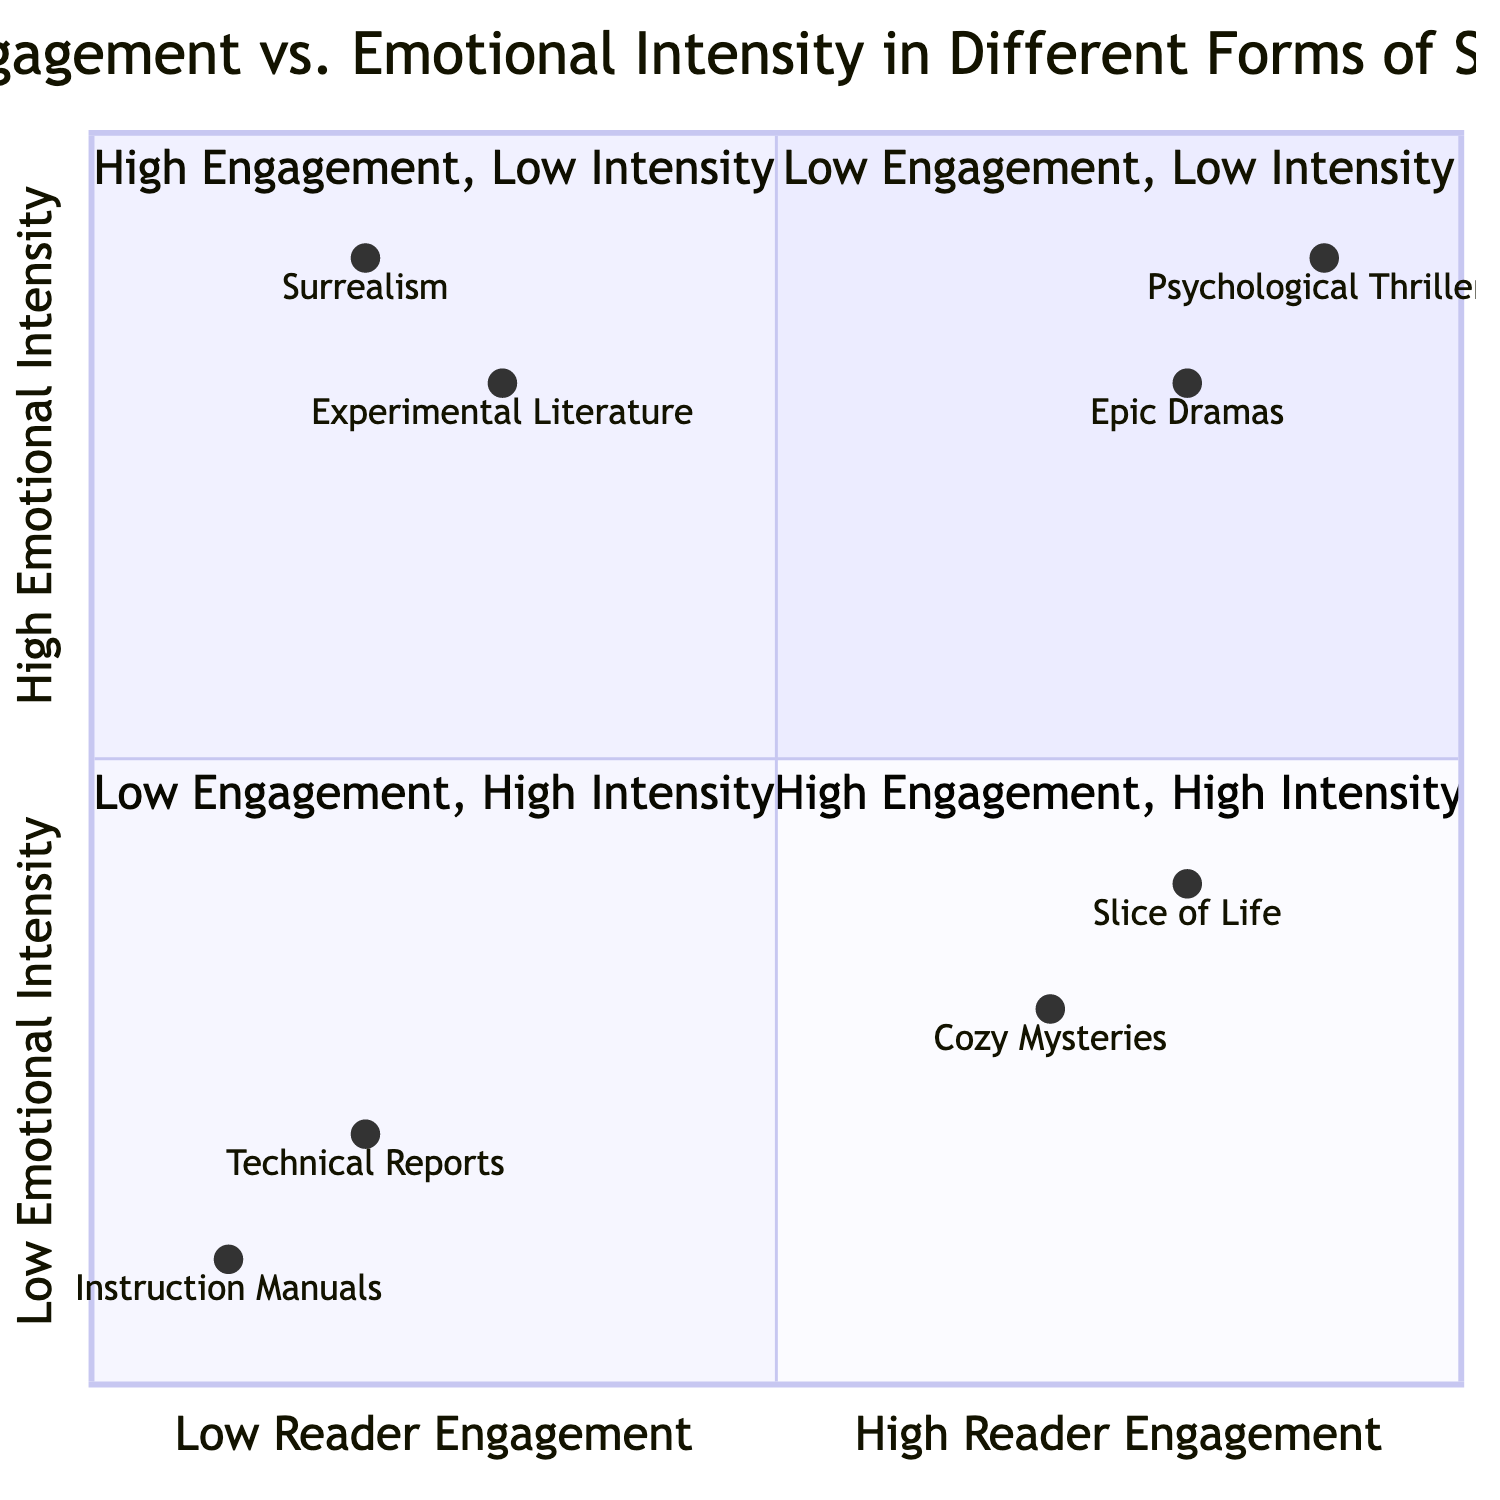What is the title of the diagram? The title is explicitly stated at the top of the diagram, which is "Reader Engagement vs. Emotional Intensity in Different Forms of Storytelling."
Answer: Reader Engagement vs. Emotional Intensity in Different Forms of Storytelling Which example has the highest reader engagement? In the quadrant titled "High Engagement, High Intensity," both "Psychological Thrillers" and "Epic Dramas" are located at high engagement levels, but "Psychological Thrillers" is further to the right on the x-axis, indicating it has the highest reader engagement.
Answer: Psychological Thrillers How many examples are in the "Low Engagement, High Intensity" quadrant? The "Low Engagement, High Intensity" quadrant contains two examples: "Experimental Literature" and "Surrealism," indicating there are a total of two examples present.
Answer: 2 What is the emotional intensity of "Cozy Mysteries"? The "Cozy Mysteries" is located in the "High Engagement, Low Intensity" quadrant, with its position indicating an emotional intensity of 0.3 on the y-axis.
Answer: 0.3 Which quadrant has emotionally intense but difficult-to-follow narratives? The quadrant labeled "Low Engagement, High Intensity" includes narratives that are emotionally intense but often difficult to follow, represented by "Experimental Literature" and "Surrealism."
Answer: Low Engagement, High Intensity What is the positioning of "Instruction Manuals" in the diagram? "Instruction Manuals" is positioned at the coordinates [0.1, 0.1], placing it in the "Low Engagement, Low Intensity" quadrant, indicating low values for both reader engagement and emotional intensity.
Answer: Low Engagement, Low Intensity Which storytelling form provides a compelling narrative with deep emotional storytelling? "Epic Dramas," located in the "High Engagement, High Intensity" quadrant, provides a compelling narrative along with deep emotional storytelling, making it the answer.
Answer: Epic Dramas What is the emotional intensity of "Surrealism"? The example "Surrealism" is positioned at a higher emotional intensity value of 0.9, indicated on the y-axis, showcasing a high level of emotional charge despite its low engagement.
Answer: 0.9 